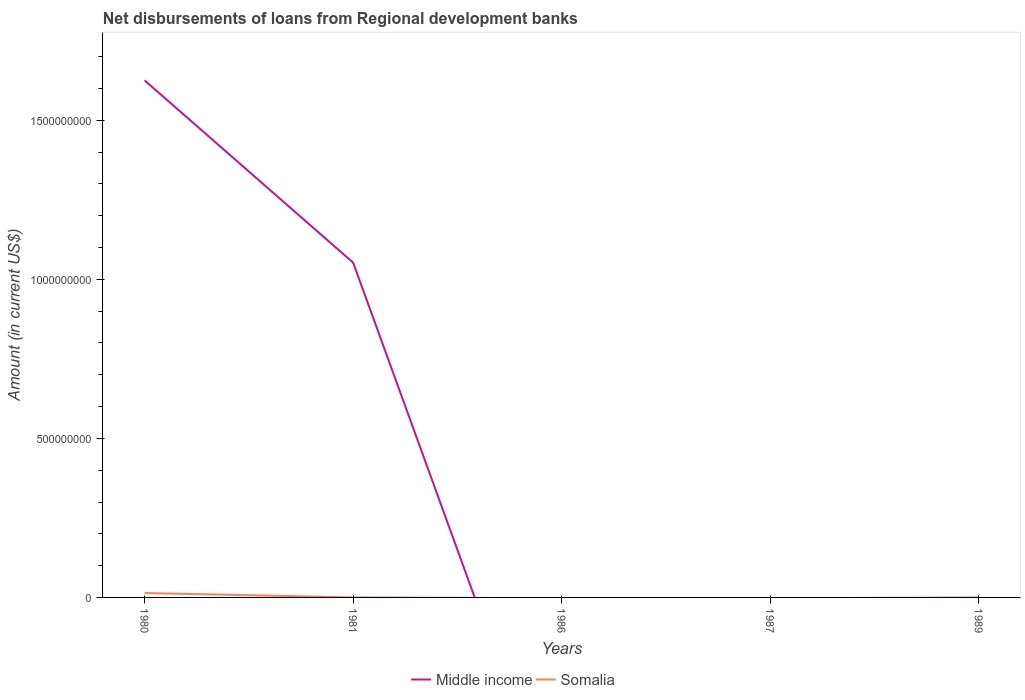How many different coloured lines are there?
Ensure brevity in your answer.  2. Across all years, what is the maximum amount of disbursements of loans from regional development banks in Middle income?
Your response must be concise. 0. What is the total amount of disbursements of loans from regional development banks in Middle income in the graph?
Make the answer very short. 5.73e+08. What is the difference between the highest and the second highest amount of disbursements of loans from regional development banks in Middle income?
Your answer should be compact. 1.63e+09. Is the amount of disbursements of loans from regional development banks in Somalia strictly greater than the amount of disbursements of loans from regional development banks in Middle income over the years?
Ensure brevity in your answer.  No. How many years are there in the graph?
Make the answer very short. 5. Are the values on the major ticks of Y-axis written in scientific E-notation?
Keep it short and to the point. No. Does the graph contain grids?
Your answer should be very brief. No. What is the title of the graph?
Give a very brief answer. Net disbursements of loans from Regional development banks. Does "Low income" appear as one of the legend labels in the graph?
Keep it short and to the point. No. What is the label or title of the X-axis?
Your response must be concise. Years. What is the Amount (in current US$) in Middle income in 1980?
Keep it short and to the point. 1.63e+09. What is the Amount (in current US$) of Somalia in 1980?
Offer a very short reply. 1.38e+07. What is the Amount (in current US$) in Middle income in 1981?
Provide a succinct answer. 1.05e+09. What is the Amount (in current US$) in Somalia in 1981?
Provide a short and direct response. 8.50e+04. What is the Amount (in current US$) of Somalia in 1987?
Your answer should be compact. 0. What is the Amount (in current US$) of Somalia in 1989?
Give a very brief answer. 0. Across all years, what is the maximum Amount (in current US$) of Middle income?
Offer a terse response. 1.63e+09. Across all years, what is the maximum Amount (in current US$) of Somalia?
Give a very brief answer. 1.38e+07. Across all years, what is the minimum Amount (in current US$) in Somalia?
Offer a terse response. 0. What is the total Amount (in current US$) in Middle income in the graph?
Make the answer very short. 2.68e+09. What is the total Amount (in current US$) of Somalia in the graph?
Provide a short and direct response. 1.39e+07. What is the difference between the Amount (in current US$) of Middle income in 1980 and that in 1981?
Offer a very short reply. 5.73e+08. What is the difference between the Amount (in current US$) of Somalia in 1980 and that in 1981?
Give a very brief answer. 1.37e+07. What is the difference between the Amount (in current US$) in Middle income in 1980 and the Amount (in current US$) in Somalia in 1981?
Provide a short and direct response. 1.63e+09. What is the average Amount (in current US$) of Middle income per year?
Your answer should be compact. 5.36e+08. What is the average Amount (in current US$) of Somalia per year?
Your answer should be compact. 2.78e+06. In the year 1980, what is the difference between the Amount (in current US$) in Middle income and Amount (in current US$) in Somalia?
Make the answer very short. 1.61e+09. In the year 1981, what is the difference between the Amount (in current US$) of Middle income and Amount (in current US$) of Somalia?
Provide a succinct answer. 1.05e+09. What is the ratio of the Amount (in current US$) of Middle income in 1980 to that in 1981?
Make the answer very short. 1.54. What is the ratio of the Amount (in current US$) of Somalia in 1980 to that in 1981?
Provide a succinct answer. 162.64. What is the difference between the highest and the lowest Amount (in current US$) of Middle income?
Give a very brief answer. 1.63e+09. What is the difference between the highest and the lowest Amount (in current US$) in Somalia?
Make the answer very short. 1.38e+07. 